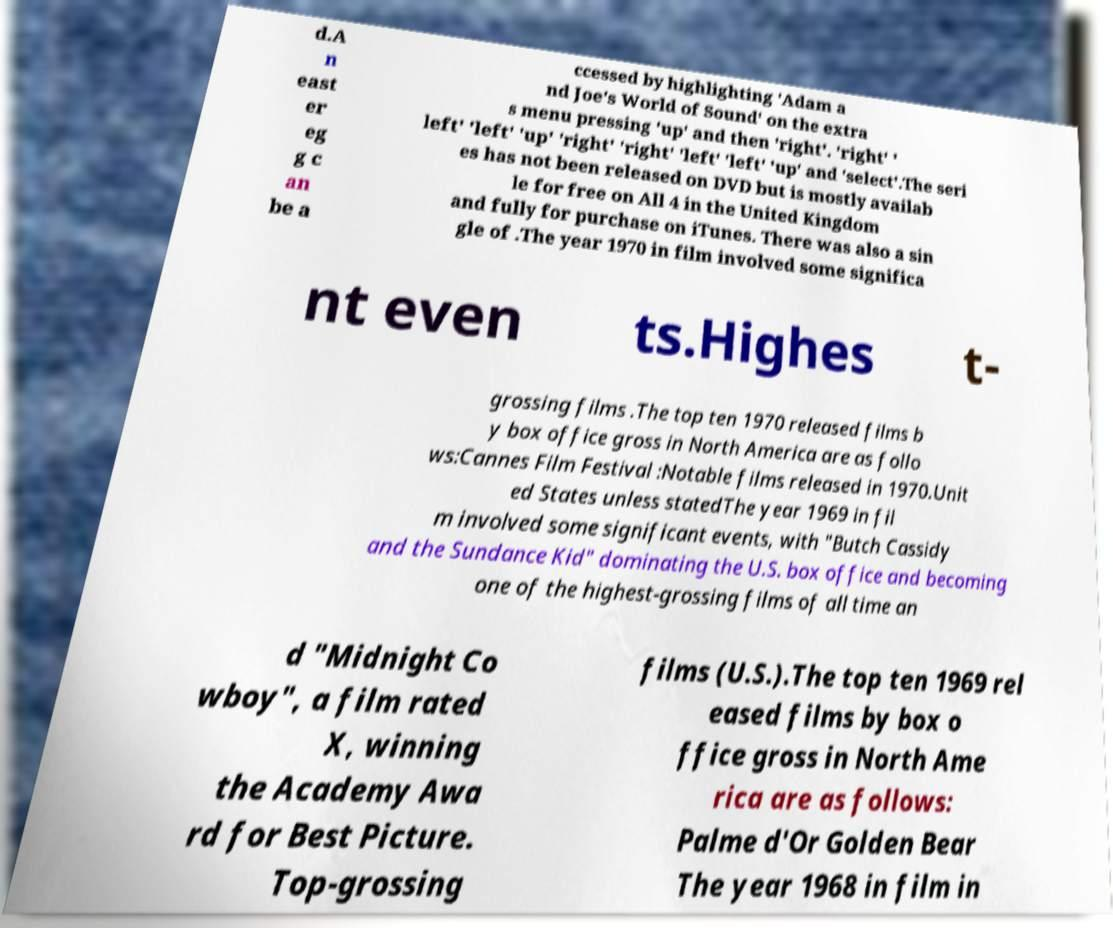I need the written content from this picture converted into text. Can you do that? d.A n east er eg g c an be a ccessed by highlighting 'Adam a nd Joe's World of Sound' on the extra s menu pressing 'up' and then 'right'. 'right' ' left' 'left' 'up' 'right' 'right' 'left' 'left' 'up' and 'select'.The seri es has not been released on DVD but is mostly availab le for free on All 4 in the United Kingdom and fully for purchase on iTunes. There was also a sin gle of .The year 1970 in film involved some significa nt even ts.Highes t- grossing films .The top ten 1970 released films b y box office gross in North America are as follo ws:Cannes Film Festival :Notable films released in 1970.Unit ed States unless statedThe year 1969 in fil m involved some significant events, with "Butch Cassidy and the Sundance Kid" dominating the U.S. box office and becoming one of the highest-grossing films of all time an d "Midnight Co wboy", a film rated X, winning the Academy Awa rd for Best Picture. Top-grossing films (U.S.).The top ten 1969 rel eased films by box o ffice gross in North Ame rica are as follows: Palme d'Or Golden Bear The year 1968 in film in 